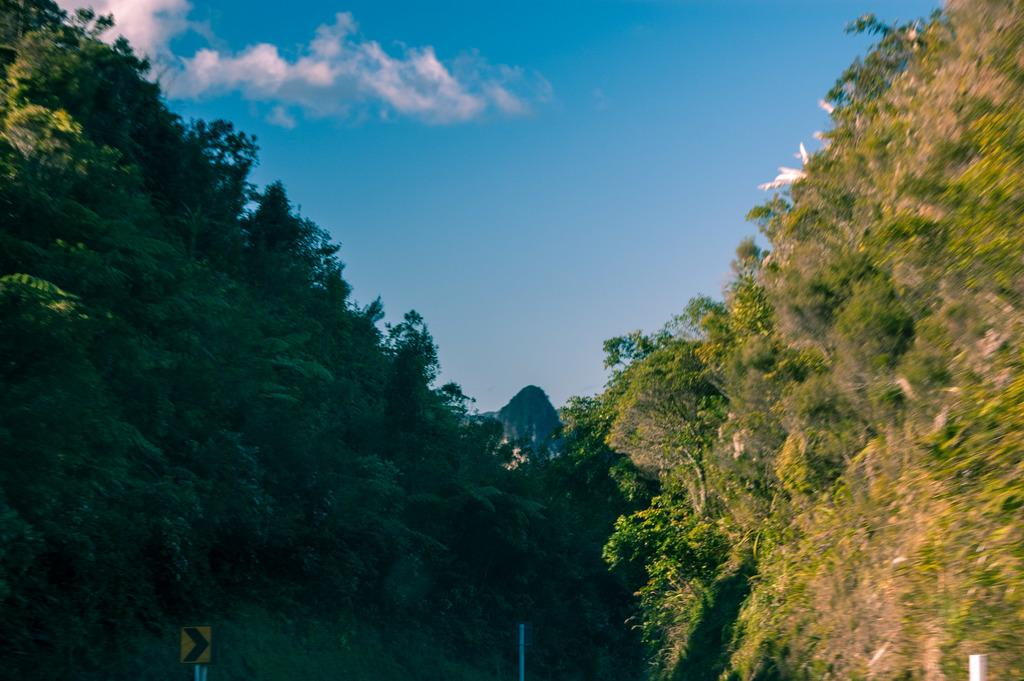What type of natural formation can be seen in the image? There are mountains in the image. What is growing on the mountains? There are trees on the mountains. What part of the sky is visible in the image? The sky is visible in the center of the image. What is located at the bottom of the image? There is a sign board at the bottom of the image. What type of father can be seen in the image? There is no father present in the image; it features mountains, trees, sky, and a sign board. 